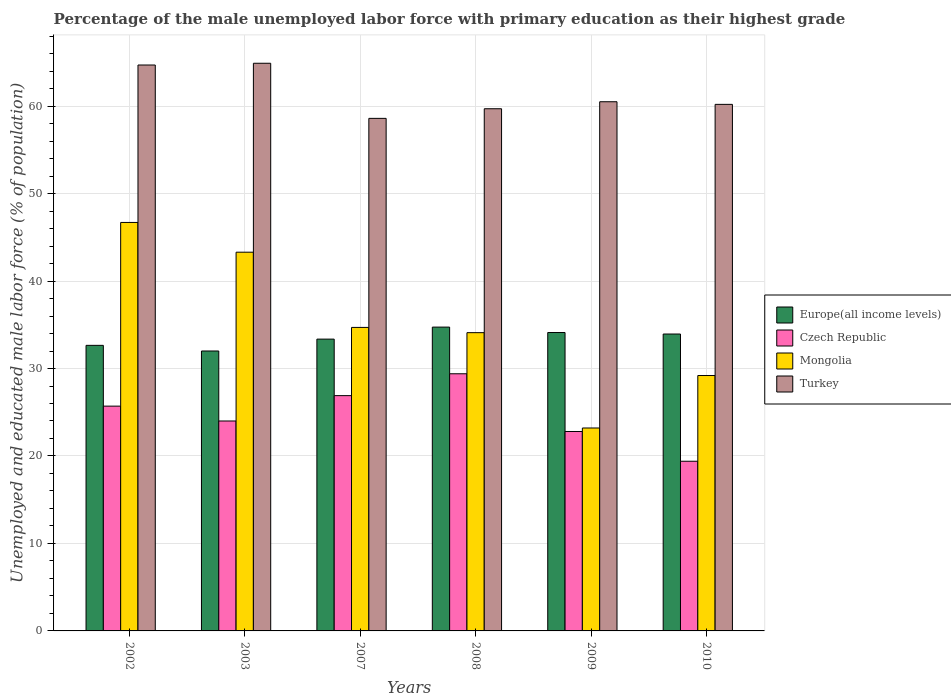How many bars are there on the 3rd tick from the right?
Your answer should be very brief. 4. What is the label of the 5th group of bars from the left?
Your answer should be compact. 2009. What is the percentage of the unemployed male labor force with primary education in Czech Republic in 2002?
Ensure brevity in your answer.  25.7. Across all years, what is the maximum percentage of the unemployed male labor force with primary education in Turkey?
Give a very brief answer. 64.9. Across all years, what is the minimum percentage of the unemployed male labor force with primary education in Mongolia?
Your answer should be compact. 23.2. What is the total percentage of the unemployed male labor force with primary education in Europe(all income levels) in the graph?
Provide a short and direct response. 200.81. What is the difference between the percentage of the unemployed male labor force with primary education in Turkey in 2002 and that in 2009?
Your answer should be compact. 4.2. What is the difference between the percentage of the unemployed male labor force with primary education in Czech Republic in 2007 and the percentage of the unemployed male labor force with primary education in Turkey in 2009?
Your response must be concise. -33.6. What is the average percentage of the unemployed male labor force with primary education in Turkey per year?
Your answer should be compact. 61.43. In the year 2003, what is the difference between the percentage of the unemployed male labor force with primary education in Europe(all income levels) and percentage of the unemployed male labor force with primary education in Mongolia?
Make the answer very short. -11.3. What is the ratio of the percentage of the unemployed male labor force with primary education in Czech Republic in 2003 to that in 2008?
Your response must be concise. 0.82. Is the percentage of the unemployed male labor force with primary education in Europe(all income levels) in 2007 less than that in 2009?
Offer a very short reply. Yes. What is the difference between the highest and the second highest percentage of the unemployed male labor force with primary education in Turkey?
Make the answer very short. 0.2. What is the difference between the highest and the lowest percentage of the unemployed male labor force with primary education in Europe(all income levels)?
Keep it short and to the point. 2.73. Is the sum of the percentage of the unemployed male labor force with primary education in Czech Republic in 2003 and 2007 greater than the maximum percentage of the unemployed male labor force with primary education in Mongolia across all years?
Provide a succinct answer. Yes. Is it the case that in every year, the sum of the percentage of the unemployed male labor force with primary education in Czech Republic and percentage of the unemployed male labor force with primary education in Mongolia is greater than the sum of percentage of the unemployed male labor force with primary education in Turkey and percentage of the unemployed male labor force with primary education in Europe(all income levels)?
Keep it short and to the point. No. What does the 1st bar from the left in 2009 represents?
Your answer should be very brief. Europe(all income levels). What does the 4th bar from the right in 2002 represents?
Provide a succinct answer. Europe(all income levels). Is it the case that in every year, the sum of the percentage of the unemployed male labor force with primary education in Czech Republic and percentage of the unemployed male labor force with primary education in Europe(all income levels) is greater than the percentage of the unemployed male labor force with primary education in Turkey?
Offer a terse response. No. Are all the bars in the graph horizontal?
Offer a very short reply. No. What is the difference between two consecutive major ticks on the Y-axis?
Ensure brevity in your answer.  10. Are the values on the major ticks of Y-axis written in scientific E-notation?
Offer a terse response. No. Where does the legend appear in the graph?
Provide a succinct answer. Center right. How are the legend labels stacked?
Your answer should be very brief. Vertical. What is the title of the graph?
Give a very brief answer. Percentage of the male unemployed labor force with primary education as their highest grade. Does "Libya" appear as one of the legend labels in the graph?
Make the answer very short. No. What is the label or title of the Y-axis?
Your answer should be very brief. Unemployed and educated male labor force (% of population). What is the Unemployed and educated male labor force (% of population) in Europe(all income levels) in 2002?
Ensure brevity in your answer.  32.65. What is the Unemployed and educated male labor force (% of population) of Czech Republic in 2002?
Provide a succinct answer. 25.7. What is the Unemployed and educated male labor force (% of population) in Mongolia in 2002?
Your answer should be very brief. 46.7. What is the Unemployed and educated male labor force (% of population) in Turkey in 2002?
Provide a succinct answer. 64.7. What is the Unemployed and educated male labor force (% of population) of Europe(all income levels) in 2003?
Provide a succinct answer. 32. What is the Unemployed and educated male labor force (% of population) of Czech Republic in 2003?
Give a very brief answer. 24. What is the Unemployed and educated male labor force (% of population) of Mongolia in 2003?
Your response must be concise. 43.3. What is the Unemployed and educated male labor force (% of population) in Turkey in 2003?
Your response must be concise. 64.9. What is the Unemployed and educated male labor force (% of population) in Europe(all income levels) in 2007?
Offer a very short reply. 33.36. What is the Unemployed and educated male labor force (% of population) of Czech Republic in 2007?
Keep it short and to the point. 26.9. What is the Unemployed and educated male labor force (% of population) of Mongolia in 2007?
Ensure brevity in your answer.  34.7. What is the Unemployed and educated male labor force (% of population) of Turkey in 2007?
Your response must be concise. 58.6. What is the Unemployed and educated male labor force (% of population) of Europe(all income levels) in 2008?
Keep it short and to the point. 34.74. What is the Unemployed and educated male labor force (% of population) in Czech Republic in 2008?
Your answer should be compact. 29.4. What is the Unemployed and educated male labor force (% of population) of Mongolia in 2008?
Your response must be concise. 34.1. What is the Unemployed and educated male labor force (% of population) in Turkey in 2008?
Offer a very short reply. 59.7. What is the Unemployed and educated male labor force (% of population) in Europe(all income levels) in 2009?
Make the answer very short. 34.12. What is the Unemployed and educated male labor force (% of population) in Czech Republic in 2009?
Provide a short and direct response. 22.8. What is the Unemployed and educated male labor force (% of population) of Mongolia in 2009?
Your answer should be compact. 23.2. What is the Unemployed and educated male labor force (% of population) in Turkey in 2009?
Your answer should be very brief. 60.5. What is the Unemployed and educated male labor force (% of population) of Europe(all income levels) in 2010?
Provide a succinct answer. 33.94. What is the Unemployed and educated male labor force (% of population) of Czech Republic in 2010?
Provide a succinct answer. 19.4. What is the Unemployed and educated male labor force (% of population) in Mongolia in 2010?
Offer a terse response. 29.2. What is the Unemployed and educated male labor force (% of population) in Turkey in 2010?
Provide a short and direct response. 60.2. Across all years, what is the maximum Unemployed and educated male labor force (% of population) of Europe(all income levels)?
Ensure brevity in your answer.  34.74. Across all years, what is the maximum Unemployed and educated male labor force (% of population) in Czech Republic?
Offer a very short reply. 29.4. Across all years, what is the maximum Unemployed and educated male labor force (% of population) of Mongolia?
Your response must be concise. 46.7. Across all years, what is the maximum Unemployed and educated male labor force (% of population) in Turkey?
Your answer should be compact. 64.9. Across all years, what is the minimum Unemployed and educated male labor force (% of population) of Europe(all income levels)?
Ensure brevity in your answer.  32. Across all years, what is the minimum Unemployed and educated male labor force (% of population) in Czech Republic?
Provide a short and direct response. 19.4. Across all years, what is the minimum Unemployed and educated male labor force (% of population) of Mongolia?
Give a very brief answer. 23.2. Across all years, what is the minimum Unemployed and educated male labor force (% of population) in Turkey?
Offer a very short reply. 58.6. What is the total Unemployed and educated male labor force (% of population) in Europe(all income levels) in the graph?
Provide a succinct answer. 200.81. What is the total Unemployed and educated male labor force (% of population) in Czech Republic in the graph?
Your answer should be very brief. 148.2. What is the total Unemployed and educated male labor force (% of population) in Mongolia in the graph?
Your answer should be compact. 211.2. What is the total Unemployed and educated male labor force (% of population) in Turkey in the graph?
Your answer should be very brief. 368.6. What is the difference between the Unemployed and educated male labor force (% of population) in Europe(all income levels) in 2002 and that in 2003?
Ensure brevity in your answer.  0.65. What is the difference between the Unemployed and educated male labor force (% of population) of Europe(all income levels) in 2002 and that in 2007?
Your answer should be compact. -0.71. What is the difference between the Unemployed and educated male labor force (% of population) of Czech Republic in 2002 and that in 2007?
Ensure brevity in your answer.  -1.2. What is the difference between the Unemployed and educated male labor force (% of population) in Turkey in 2002 and that in 2007?
Your answer should be very brief. 6.1. What is the difference between the Unemployed and educated male labor force (% of population) in Europe(all income levels) in 2002 and that in 2008?
Provide a short and direct response. -2.09. What is the difference between the Unemployed and educated male labor force (% of population) of Czech Republic in 2002 and that in 2008?
Provide a short and direct response. -3.7. What is the difference between the Unemployed and educated male labor force (% of population) of Turkey in 2002 and that in 2008?
Ensure brevity in your answer.  5. What is the difference between the Unemployed and educated male labor force (% of population) in Europe(all income levels) in 2002 and that in 2009?
Give a very brief answer. -1.47. What is the difference between the Unemployed and educated male labor force (% of population) in Mongolia in 2002 and that in 2009?
Offer a very short reply. 23.5. What is the difference between the Unemployed and educated male labor force (% of population) of Europe(all income levels) in 2002 and that in 2010?
Keep it short and to the point. -1.3. What is the difference between the Unemployed and educated male labor force (% of population) of Europe(all income levels) in 2003 and that in 2007?
Provide a succinct answer. -1.36. What is the difference between the Unemployed and educated male labor force (% of population) in Czech Republic in 2003 and that in 2007?
Make the answer very short. -2.9. What is the difference between the Unemployed and educated male labor force (% of population) of Mongolia in 2003 and that in 2007?
Offer a terse response. 8.6. What is the difference between the Unemployed and educated male labor force (% of population) in Turkey in 2003 and that in 2007?
Keep it short and to the point. 6.3. What is the difference between the Unemployed and educated male labor force (% of population) in Europe(all income levels) in 2003 and that in 2008?
Give a very brief answer. -2.73. What is the difference between the Unemployed and educated male labor force (% of population) in Czech Republic in 2003 and that in 2008?
Your answer should be compact. -5.4. What is the difference between the Unemployed and educated male labor force (% of population) in Mongolia in 2003 and that in 2008?
Your response must be concise. 9.2. What is the difference between the Unemployed and educated male labor force (% of population) of Europe(all income levels) in 2003 and that in 2009?
Provide a short and direct response. -2.11. What is the difference between the Unemployed and educated male labor force (% of population) of Czech Republic in 2003 and that in 2009?
Give a very brief answer. 1.2. What is the difference between the Unemployed and educated male labor force (% of population) of Mongolia in 2003 and that in 2009?
Your response must be concise. 20.1. What is the difference between the Unemployed and educated male labor force (% of population) of Turkey in 2003 and that in 2009?
Provide a short and direct response. 4.4. What is the difference between the Unemployed and educated male labor force (% of population) in Europe(all income levels) in 2003 and that in 2010?
Keep it short and to the point. -1.94. What is the difference between the Unemployed and educated male labor force (% of population) of Mongolia in 2003 and that in 2010?
Ensure brevity in your answer.  14.1. What is the difference between the Unemployed and educated male labor force (% of population) of Europe(all income levels) in 2007 and that in 2008?
Keep it short and to the point. -1.37. What is the difference between the Unemployed and educated male labor force (% of population) in Czech Republic in 2007 and that in 2008?
Keep it short and to the point. -2.5. What is the difference between the Unemployed and educated male labor force (% of population) in Mongolia in 2007 and that in 2008?
Offer a very short reply. 0.6. What is the difference between the Unemployed and educated male labor force (% of population) in Europe(all income levels) in 2007 and that in 2009?
Make the answer very short. -0.75. What is the difference between the Unemployed and educated male labor force (% of population) in Czech Republic in 2007 and that in 2009?
Your answer should be very brief. 4.1. What is the difference between the Unemployed and educated male labor force (% of population) of Turkey in 2007 and that in 2009?
Offer a very short reply. -1.9. What is the difference between the Unemployed and educated male labor force (% of population) of Europe(all income levels) in 2007 and that in 2010?
Your answer should be very brief. -0.58. What is the difference between the Unemployed and educated male labor force (% of population) in Mongolia in 2007 and that in 2010?
Your answer should be compact. 5.5. What is the difference between the Unemployed and educated male labor force (% of population) of Europe(all income levels) in 2008 and that in 2009?
Offer a terse response. 0.62. What is the difference between the Unemployed and educated male labor force (% of population) of Czech Republic in 2008 and that in 2009?
Make the answer very short. 6.6. What is the difference between the Unemployed and educated male labor force (% of population) in Mongolia in 2008 and that in 2009?
Provide a succinct answer. 10.9. What is the difference between the Unemployed and educated male labor force (% of population) of Europe(all income levels) in 2008 and that in 2010?
Keep it short and to the point. 0.79. What is the difference between the Unemployed and educated male labor force (% of population) of Turkey in 2008 and that in 2010?
Ensure brevity in your answer.  -0.5. What is the difference between the Unemployed and educated male labor force (% of population) of Europe(all income levels) in 2009 and that in 2010?
Your response must be concise. 0.17. What is the difference between the Unemployed and educated male labor force (% of population) of Czech Republic in 2009 and that in 2010?
Give a very brief answer. 3.4. What is the difference between the Unemployed and educated male labor force (% of population) in Europe(all income levels) in 2002 and the Unemployed and educated male labor force (% of population) in Czech Republic in 2003?
Offer a terse response. 8.65. What is the difference between the Unemployed and educated male labor force (% of population) in Europe(all income levels) in 2002 and the Unemployed and educated male labor force (% of population) in Mongolia in 2003?
Ensure brevity in your answer.  -10.65. What is the difference between the Unemployed and educated male labor force (% of population) of Europe(all income levels) in 2002 and the Unemployed and educated male labor force (% of population) of Turkey in 2003?
Ensure brevity in your answer.  -32.25. What is the difference between the Unemployed and educated male labor force (% of population) in Czech Republic in 2002 and the Unemployed and educated male labor force (% of population) in Mongolia in 2003?
Make the answer very short. -17.6. What is the difference between the Unemployed and educated male labor force (% of population) of Czech Republic in 2002 and the Unemployed and educated male labor force (% of population) of Turkey in 2003?
Make the answer very short. -39.2. What is the difference between the Unemployed and educated male labor force (% of population) in Mongolia in 2002 and the Unemployed and educated male labor force (% of population) in Turkey in 2003?
Your answer should be very brief. -18.2. What is the difference between the Unemployed and educated male labor force (% of population) in Europe(all income levels) in 2002 and the Unemployed and educated male labor force (% of population) in Czech Republic in 2007?
Offer a very short reply. 5.75. What is the difference between the Unemployed and educated male labor force (% of population) in Europe(all income levels) in 2002 and the Unemployed and educated male labor force (% of population) in Mongolia in 2007?
Your answer should be very brief. -2.05. What is the difference between the Unemployed and educated male labor force (% of population) of Europe(all income levels) in 2002 and the Unemployed and educated male labor force (% of population) of Turkey in 2007?
Ensure brevity in your answer.  -25.95. What is the difference between the Unemployed and educated male labor force (% of population) in Czech Republic in 2002 and the Unemployed and educated male labor force (% of population) in Mongolia in 2007?
Your answer should be very brief. -9. What is the difference between the Unemployed and educated male labor force (% of population) of Czech Republic in 2002 and the Unemployed and educated male labor force (% of population) of Turkey in 2007?
Make the answer very short. -32.9. What is the difference between the Unemployed and educated male labor force (% of population) in Europe(all income levels) in 2002 and the Unemployed and educated male labor force (% of population) in Czech Republic in 2008?
Provide a succinct answer. 3.25. What is the difference between the Unemployed and educated male labor force (% of population) in Europe(all income levels) in 2002 and the Unemployed and educated male labor force (% of population) in Mongolia in 2008?
Offer a terse response. -1.45. What is the difference between the Unemployed and educated male labor force (% of population) in Europe(all income levels) in 2002 and the Unemployed and educated male labor force (% of population) in Turkey in 2008?
Your answer should be compact. -27.05. What is the difference between the Unemployed and educated male labor force (% of population) in Czech Republic in 2002 and the Unemployed and educated male labor force (% of population) in Turkey in 2008?
Provide a short and direct response. -34. What is the difference between the Unemployed and educated male labor force (% of population) of Mongolia in 2002 and the Unemployed and educated male labor force (% of population) of Turkey in 2008?
Give a very brief answer. -13. What is the difference between the Unemployed and educated male labor force (% of population) in Europe(all income levels) in 2002 and the Unemployed and educated male labor force (% of population) in Czech Republic in 2009?
Provide a short and direct response. 9.85. What is the difference between the Unemployed and educated male labor force (% of population) of Europe(all income levels) in 2002 and the Unemployed and educated male labor force (% of population) of Mongolia in 2009?
Your response must be concise. 9.45. What is the difference between the Unemployed and educated male labor force (% of population) of Europe(all income levels) in 2002 and the Unemployed and educated male labor force (% of population) of Turkey in 2009?
Make the answer very short. -27.85. What is the difference between the Unemployed and educated male labor force (% of population) in Czech Republic in 2002 and the Unemployed and educated male labor force (% of population) in Mongolia in 2009?
Keep it short and to the point. 2.5. What is the difference between the Unemployed and educated male labor force (% of population) of Czech Republic in 2002 and the Unemployed and educated male labor force (% of population) of Turkey in 2009?
Provide a short and direct response. -34.8. What is the difference between the Unemployed and educated male labor force (% of population) of Europe(all income levels) in 2002 and the Unemployed and educated male labor force (% of population) of Czech Republic in 2010?
Your response must be concise. 13.25. What is the difference between the Unemployed and educated male labor force (% of population) in Europe(all income levels) in 2002 and the Unemployed and educated male labor force (% of population) in Mongolia in 2010?
Provide a succinct answer. 3.45. What is the difference between the Unemployed and educated male labor force (% of population) of Europe(all income levels) in 2002 and the Unemployed and educated male labor force (% of population) of Turkey in 2010?
Give a very brief answer. -27.55. What is the difference between the Unemployed and educated male labor force (% of population) of Czech Republic in 2002 and the Unemployed and educated male labor force (% of population) of Turkey in 2010?
Provide a succinct answer. -34.5. What is the difference between the Unemployed and educated male labor force (% of population) in Europe(all income levels) in 2003 and the Unemployed and educated male labor force (% of population) in Czech Republic in 2007?
Provide a succinct answer. 5.1. What is the difference between the Unemployed and educated male labor force (% of population) of Europe(all income levels) in 2003 and the Unemployed and educated male labor force (% of population) of Mongolia in 2007?
Keep it short and to the point. -2.7. What is the difference between the Unemployed and educated male labor force (% of population) in Europe(all income levels) in 2003 and the Unemployed and educated male labor force (% of population) in Turkey in 2007?
Make the answer very short. -26.6. What is the difference between the Unemployed and educated male labor force (% of population) in Czech Republic in 2003 and the Unemployed and educated male labor force (% of population) in Mongolia in 2007?
Provide a succinct answer. -10.7. What is the difference between the Unemployed and educated male labor force (% of population) in Czech Republic in 2003 and the Unemployed and educated male labor force (% of population) in Turkey in 2007?
Offer a terse response. -34.6. What is the difference between the Unemployed and educated male labor force (% of population) of Mongolia in 2003 and the Unemployed and educated male labor force (% of population) of Turkey in 2007?
Keep it short and to the point. -15.3. What is the difference between the Unemployed and educated male labor force (% of population) of Europe(all income levels) in 2003 and the Unemployed and educated male labor force (% of population) of Czech Republic in 2008?
Provide a succinct answer. 2.6. What is the difference between the Unemployed and educated male labor force (% of population) of Europe(all income levels) in 2003 and the Unemployed and educated male labor force (% of population) of Mongolia in 2008?
Provide a short and direct response. -2.1. What is the difference between the Unemployed and educated male labor force (% of population) in Europe(all income levels) in 2003 and the Unemployed and educated male labor force (% of population) in Turkey in 2008?
Offer a very short reply. -27.7. What is the difference between the Unemployed and educated male labor force (% of population) of Czech Republic in 2003 and the Unemployed and educated male labor force (% of population) of Turkey in 2008?
Your answer should be very brief. -35.7. What is the difference between the Unemployed and educated male labor force (% of population) in Mongolia in 2003 and the Unemployed and educated male labor force (% of population) in Turkey in 2008?
Provide a succinct answer. -16.4. What is the difference between the Unemployed and educated male labor force (% of population) in Europe(all income levels) in 2003 and the Unemployed and educated male labor force (% of population) in Czech Republic in 2009?
Your answer should be compact. 9.2. What is the difference between the Unemployed and educated male labor force (% of population) of Europe(all income levels) in 2003 and the Unemployed and educated male labor force (% of population) of Mongolia in 2009?
Give a very brief answer. 8.8. What is the difference between the Unemployed and educated male labor force (% of population) in Europe(all income levels) in 2003 and the Unemployed and educated male labor force (% of population) in Turkey in 2009?
Provide a short and direct response. -28.5. What is the difference between the Unemployed and educated male labor force (% of population) of Czech Republic in 2003 and the Unemployed and educated male labor force (% of population) of Mongolia in 2009?
Offer a terse response. 0.8. What is the difference between the Unemployed and educated male labor force (% of population) of Czech Republic in 2003 and the Unemployed and educated male labor force (% of population) of Turkey in 2009?
Make the answer very short. -36.5. What is the difference between the Unemployed and educated male labor force (% of population) in Mongolia in 2003 and the Unemployed and educated male labor force (% of population) in Turkey in 2009?
Provide a succinct answer. -17.2. What is the difference between the Unemployed and educated male labor force (% of population) in Europe(all income levels) in 2003 and the Unemployed and educated male labor force (% of population) in Czech Republic in 2010?
Your answer should be very brief. 12.6. What is the difference between the Unemployed and educated male labor force (% of population) of Europe(all income levels) in 2003 and the Unemployed and educated male labor force (% of population) of Mongolia in 2010?
Keep it short and to the point. 2.8. What is the difference between the Unemployed and educated male labor force (% of population) in Europe(all income levels) in 2003 and the Unemployed and educated male labor force (% of population) in Turkey in 2010?
Give a very brief answer. -28.2. What is the difference between the Unemployed and educated male labor force (% of population) in Czech Republic in 2003 and the Unemployed and educated male labor force (% of population) in Turkey in 2010?
Your answer should be very brief. -36.2. What is the difference between the Unemployed and educated male labor force (% of population) in Mongolia in 2003 and the Unemployed and educated male labor force (% of population) in Turkey in 2010?
Your answer should be very brief. -16.9. What is the difference between the Unemployed and educated male labor force (% of population) of Europe(all income levels) in 2007 and the Unemployed and educated male labor force (% of population) of Czech Republic in 2008?
Your answer should be compact. 3.96. What is the difference between the Unemployed and educated male labor force (% of population) of Europe(all income levels) in 2007 and the Unemployed and educated male labor force (% of population) of Mongolia in 2008?
Offer a very short reply. -0.74. What is the difference between the Unemployed and educated male labor force (% of population) of Europe(all income levels) in 2007 and the Unemployed and educated male labor force (% of population) of Turkey in 2008?
Make the answer very short. -26.34. What is the difference between the Unemployed and educated male labor force (% of population) in Czech Republic in 2007 and the Unemployed and educated male labor force (% of population) in Mongolia in 2008?
Your response must be concise. -7.2. What is the difference between the Unemployed and educated male labor force (% of population) in Czech Republic in 2007 and the Unemployed and educated male labor force (% of population) in Turkey in 2008?
Provide a short and direct response. -32.8. What is the difference between the Unemployed and educated male labor force (% of population) of Mongolia in 2007 and the Unemployed and educated male labor force (% of population) of Turkey in 2008?
Provide a short and direct response. -25. What is the difference between the Unemployed and educated male labor force (% of population) in Europe(all income levels) in 2007 and the Unemployed and educated male labor force (% of population) in Czech Republic in 2009?
Offer a very short reply. 10.56. What is the difference between the Unemployed and educated male labor force (% of population) in Europe(all income levels) in 2007 and the Unemployed and educated male labor force (% of population) in Mongolia in 2009?
Provide a succinct answer. 10.16. What is the difference between the Unemployed and educated male labor force (% of population) of Europe(all income levels) in 2007 and the Unemployed and educated male labor force (% of population) of Turkey in 2009?
Your answer should be compact. -27.14. What is the difference between the Unemployed and educated male labor force (% of population) of Czech Republic in 2007 and the Unemployed and educated male labor force (% of population) of Turkey in 2009?
Give a very brief answer. -33.6. What is the difference between the Unemployed and educated male labor force (% of population) in Mongolia in 2007 and the Unemployed and educated male labor force (% of population) in Turkey in 2009?
Provide a short and direct response. -25.8. What is the difference between the Unemployed and educated male labor force (% of population) in Europe(all income levels) in 2007 and the Unemployed and educated male labor force (% of population) in Czech Republic in 2010?
Offer a terse response. 13.96. What is the difference between the Unemployed and educated male labor force (% of population) in Europe(all income levels) in 2007 and the Unemployed and educated male labor force (% of population) in Mongolia in 2010?
Make the answer very short. 4.16. What is the difference between the Unemployed and educated male labor force (% of population) of Europe(all income levels) in 2007 and the Unemployed and educated male labor force (% of population) of Turkey in 2010?
Provide a succinct answer. -26.84. What is the difference between the Unemployed and educated male labor force (% of population) in Czech Republic in 2007 and the Unemployed and educated male labor force (% of population) in Turkey in 2010?
Offer a very short reply. -33.3. What is the difference between the Unemployed and educated male labor force (% of population) of Mongolia in 2007 and the Unemployed and educated male labor force (% of population) of Turkey in 2010?
Your response must be concise. -25.5. What is the difference between the Unemployed and educated male labor force (% of population) in Europe(all income levels) in 2008 and the Unemployed and educated male labor force (% of population) in Czech Republic in 2009?
Your answer should be very brief. 11.94. What is the difference between the Unemployed and educated male labor force (% of population) in Europe(all income levels) in 2008 and the Unemployed and educated male labor force (% of population) in Mongolia in 2009?
Provide a succinct answer. 11.54. What is the difference between the Unemployed and educated male labor force (% of population) in Europe(all income levels) in 2008 and the Unemployed and educated male labor force (% of population) in Turkey in 2009?
Provide a succinct answer. -25.76. What is the difference between the Unemployed and educated male labor force (% of population) of Czech Republic in 2008 and the Unemployed and educated male labor force (% of population) of Turkey in 2009?
Give a very brief answer. -31.1. What is the difference between the Unemployed and educated male labor force (% of population) of Mongolia in 2008 and the Unemployed and educated male labor force (% of population) of Turkey in 2009?
Offer a very short reply. -26.4. What is the difference between the Unemployed and educated male labor force (% of population) of Europe(all income levels) in 2008 and the Unemployed and educated male labor force (% of population) of Czech Republic in 2010?
Make the answer very short. 15.34. What is the difference between the Unemployed and educated male labor force (% of population) of Europe(all income levels) in 2008 and the Unemployed and educated male labor force (% of population) of Mongolia in 2010?
Your answer should be very brief. 5.54. What is the difference between the Unemployed and educated male labor force (% of population) of Europe(all income levels) in 2008 and the Unemployed and educated male labor force (% of population) of Turkey in 2010?
Make the answer very short. -25.46. What is the difference between the Unemployed and educated male labor force (% of population) of Czech Republic in 2008 and the Unemployed and educated male labor force (% of population) of Mongolia in 2010?
Your response must be concise. 0.2. What is the difference between the Unemployed and educated male labor force (% of population) of Czech Republic in 2008 and the Unemployed and educated male labor force (% of population) of Turkey in 2010?
Offer a very short reply. -30.8. What is the difference between the Unemployed and educated male labor force (% of population) in Mongolia in 2008 and the Unemployed and educated male labor force (% of population) in Turkey in 2010?
Your answer should be compact. -26.1. What is the difference between the Unemployed and educated male labor force (% of population) in Europe(all income levels) in 2009 and the Unemployed and educated male labor force (% of population) in Czech Republic in 2010?
Your answer should be very brief. 14.72. What is the difference between the Unemployed and educated male labor force (% of population) of Europe(all income levels) in 2009 and the Unemployed and educated male labor force (% of population) of Mongolia in 2010?
Give a very brief answer. 4.92. What is the difference between the Unemployed and educated male labor force (% of population) of Europe(all income levels) in 2009 and the Unemployed and educated male labor force (% of population) of Turkey in 2010?
Provide a succinct answer. -26.08. What is the difference between the Unemployed and educated male labor force (% of population) in Czech Republic in 2009 and the Unemployed and educated male labor force (% of population) in Mongolia in 2010?
Your answer should be very brief. -6.4. What is the difference between the Unemployed and educated male labor force (% of population) of Czech Republic in 2009 and the Unemployed and educated male labor force (% of population) of Turkey in 2010?
Your answer should be compact. -37.4. What is the difference between the Unemployed and educated male labor force (% of population) in Mongolia in 2009 and the Unemployed and educated male labor force (% of population) in Turkey in 2010?
Your response must be concise. -37. What is the average Unemployed and educated male labor force (% of population) in Europe(all income levels) per year?
Provide a short and direct response. 33.47. What is the average Unemployed and educated male labor force (% of population) in Czech Republic per year?
Offer a terse response. 24.7. What is the average Unemployed and educated male labor force (% of population) in Mongolia per year?
Your answer should be very brief. 35.2. What is the average Unemployed and educated male labor force (% of population) of Turkey per year?
Ensure brevity in your answer.  61.43. In the year 2002, what is the difference between the Unemployed and educated male labor force (% of population) in Europe(all income levels) and Unemployed and educated male labor force (% of population) in Czech Republic?
Ensure brevity in your answer.  6.95. In the year 2002, what is the difference between the Unemployed and educated male labor force (% of population) in Europe(all income levels) and Unemployed and educated male labor force (% of population) in Mongolia?
Offer a terse response. -14.05. In the year 2002, what is the difference between the Unemployed and educated male labor force (% of population) of Europe(all income levels) and Unemployed and educated male labor force (% of population) of Turkey?
Keep it short and to the point. -32.05. In the year 2002, what is the difference between the Unemployed and educated male labor force (% of population) of Czech Republic and Unemployed and educated male labor force (% of population) of Turkey?
Offer a very short reply. -39. In the year 2003, what is the difference between the Unemployed and educated male labor force (% of population) of Europe(all income levels) and Unemployed and educated male labor force (% of population) of Czech Republic?
Your response must be concise. 8. In the year 2003, what is the difference between the Unemployed and educated male labor force (% of population) in Europe(all income levels) and Unemployed and educated male labor force (% of population) in Mongolia?
Your answer should be compact. -11.3. In the year 2003, what is the difference between the Unemployed and educated male labor force (% of population) in Europe(all income levels) and Unemployed and educated male labor force (% of population) in Turkey?
Ensure brevity in your answer.  -32.9. In the year 2003, what is the difference between the Unemployed and educated male labor force (% of population) of Czech Republic and Unemployed and educated male labor force (% of population) of Mongolia?
Your answer should be compact. -19.3. In the year 2003, what is the difference between the Unemployed and educated male labor force (% of population) of Czech Republic and Unemployed and educated male labor force (% of population) of Turkey?
Keep it short and to the point. -40.9. In the year 2003, what is the difference between the Unemployed and educated male labor force (% of population) in Mongolia and Unemployed and educated male labor force (% of population) in Turkey?
Provide a succinct answer. -21.6. In the year 2007, what is the difference between the Unemployed and educated male labor force (% of population) in Europe(all income levels) and Unemployed and educated male labor force (% of population) in Czech Republic?
Make the answer very short. 6.46. In the year 2007, what is the difference between the Unemployed and educated male labor force (% of population) of Europe(all income levels) and Unemployed and educated male labor force (% of population) of Mongolia?
Your response must be concise. -1.34. In the year 2007, what is the difference between the Unemployed and educated male labor force (% of population) in Europe(all income levels) and Unemployed and educated male labor force (% of population) in Turkey?
Offer a very short reply. -25.24. In the year 2007, what is the difference between the Unemployed and educated male labor force (% of population) in Czech Republic and Unemployed and educated male labor force (% of population) in Turkey?
Your answer should be very brief. -31.7. In the year 2007, what is the difference between the Unemployed and educated male labor force (% of population) in Mongolia and Unemployed and educated male labor force (% of population) in Turkey?
Provide a short and direct response. -23.9. In the year 2008, what is the difference between the Unemployed and educated male labor force (% of population) of Europe(all income levels) and Unemployed and educated male labor force (% of population) of Czech Republic?
Your response must be concise. 5.34. In the year 2008, what is the difference between the Unemployed and educated male labor force (% of population) of Europe(all income levels) and Unemployed and educated male labor force (% of population) of Mongolia?
Your response must be concise. 0.64. In the year 2008, what is the difference between the Unemployed and educated male labor force (% of population) of Europe(all income levels) and Unemployed and educated male labor force (% of population) of Turkey?
Provide a short and direct response. -24.96. In the year 2008, what is the difference between the Unemployed and educated male labor force (% of population) in Czech Republic and Unemployed and educated male labor force (% of population) in Mongolia?
Provide a short and direct response. -4.7. In the year 2008, what is the difference between the Unemployed and educated male labor force (% of population) in Czech Republic and Unemployed and educated male labor force (% of population) in Turkey?
Offer a very short reply. -30.3. In the year 2008, what is the difference between the Unemployed and educated male labor force (% of population) of Mongolia and Unemployed and educated male labor force (% of population) of Turkey?
Your answer should be compact. -25.6. In the year 2009, what is the difference between the Unemployed and educated male labor force (% of population) of Europe(all income levels) and Unemployed and educated male labor force (% of population) of Czech Republic?
Ensure brevity in your answer.  11.32. In the year 2009, what is the difference between the Unemployed and educated male labor force (% of population) of Europe(all income levels) and Unemployed and educated male labor force (% of population) of Mongolia?
Ensure brevity in your answer.  10.92. In the year 2009, what is the difference between the Unemployed and educated male labor force (% of population) in Europe(all income levels) and Unemployed and educated male labor force (% of population) in Turkey?
Your response must be concise. -26.38. In the year 2009, what is the difference between the Unemployed and educated male labor force (% of population) in Czech Republic and Unemployed and educated male labor force (% of population) in Turkey?
Your answer should be very brief. -37.7. In the year 2009, what is the difference between the Unemployed and educated male labor force (% of population) of Mongolia and Unemployed and educated male labor force (% of population) of Turkey?
Your response must be concise. -37.3. In the year 2010, what is the difference between the Unemployed and educated male labor force (% of population) in Europe(all income levels) and Unemployed and educated male labor force (% of population) in Czech Republic?
Offer a very short reply. 14.54. In the year 2010, what is the difference between the Unemployed and educated male labor force (% of population) of Europe(all income levels) and Unemployed and educated male labor force (% of population) of Mongolia?
Ensure brevity in your answer.  4.74. In the year 2010, what is the difference between the Unemployed and educated male labor force (% of population) in Europe(all income levels) and Unemployed and educated male labor force (% of population) in Turkey?
Provide a short and direct response. -26.26. In the year 2010, what is the difference between the Unemployed and educated male labor force (% of population) of Czech Republic and Unemployed and educated male labor force (% of population) of Turkey?
Ensure brevity in your answer.  -40.8. In the year 2010, what is the difference between the Unemployed and educated male labor force (% of population) in Mongolia and Unemployed and educated male labor force (% of population) in Turkey?
Keep it short and to the point. -31. What is the ratio of the Unemployed and educated male labor force (% of population) in Europe(all income levels) in 2002 to that in 2003?
Keep it short and to the point. 1.02. What is the ratio of the Unemployed and educated male labor force (% of population) of Czech Republic in 2002 to that in 2003?
Your answer should be compact. 1.07. What is the ratio of the Unemployed and educated male labor force (% of population) of Mongolia in 2002 to that in 2003?
Provide a succinct answer. 1.08. What is the ratio of the Unemployed and educated male labor force (% of population) in Turkey in 2002 to that in 2003?
Give a very brief answer. 1. What is the ratio of the Unemployed and educated male labor force (% of population) of Europe(all income levels) in 2002 to that in 2007?
Provide a short and direct response. 0.98. What is the ratio of the Unemployed and educated male labor force (% of population) of Czech Republic in 2002 to that in 2007?
Your answer should be very brief. 0.96. What is the ratio of the Unemployed and educated male labor force (% of population) of Mongolia in 2002 to that in 2007?
Provide a short and direct response. 1.35. What is the ratio of the Unemployed and educated male labor force (% of population) in Turkey in 2002 to that in 2007?
Give a very brief answer. 1.1. What is the ratio of the Unemployed and educated male labor force (% of population) in Europe(all income levels) in 2002 to that in 2008?
Ensure brevity in your answer.  0.94. What is the ratio of the Unemployed and educated male labor force (% of population) of Czech Republic in 2002 to that in 2008?
Offer a terse response. 0.87. What is the ratio of the Unemployed and educated male labor force (% of population) in Mongolia in 2002 to that in 2008?
Your answer should be compact. 1.37. What is the ratio of the Unemployed and educated male labor force (% of population) of Turkey in 2002 to that in 2008?
Your answer should be very brief. 1.08. What is the ratio of the Unemployed and educated male labor force (% of population) of Czech Republic in 2002 to that in 2009?
Offer a terse response. 1.13. What is the ratio of the Unemployed and educated male labor force (% of population) of Mongolia in 2002 to that in 2009?
Make the answer very short. 2.01. What is the ratio of the Unemployed and educated male labor force (% of population) in Turkey in 2002 to that in 2009?
Give a very brief answer. 1.07. What is the ratio of the Unemployed and educated male labor force (% of population) of Europe(all income levels) in 2002 to that in 2010?
Your response must be concise. 0.96. What is the ratio of the Unemployed and educated male labor force (% of population) in Czech Republic in 2002 to that in 2010?
Give a very brief answer. 1.32. What is the ratio of the Unemployed and educated male labor force (% of population) in Mongolia in 2002 to that in 2010?
Offer a terse response. 1.6. What is the ratio of the Unemployed and educated male labor force (% of population) in Turkey in 2002 to that in 2010?
Ensure brevity in your answer.  1.07. What is the ratio of the Unemployed and educated male labor force (% of population) in Europe(all income levels) in 2003 to that in 2007?
Offer a very short reply. 0.96. What is the ratio of the Unemployed and educated male labor force (% of population) in Czech Republic in 2003 to that in 2007?
Make the answer very short. 0.89. What is the ratio of the Unemployed and educated male labor force (% of population) of Mongolia in 2003 to that in 2007?
Keep it short and to the point. 1.25. What is the ratio of the Unemployed and educated male labor force (% of population) of Turkey in 2003 to that in 2007?
Ensure brevity in your answer.  1.11. What is the ratio of the Unemployed and educated male labor force (% of population) of Europe(all income levels) in 2003 to that in 2008?
Give a very brief answer. 0.92. What is the ratio of the Unemployed and educated male labor force (% of population) in Czech Republic in 2003 to that in 2008?
Give a very brief answer. 0.82. What is the ratio of the Unemployed and educated male labor force (% of population) of Mongolia in 2003 to that in 2008?
Ensure brevity in your answer.  1.27. What is the ratio of the Unemployed and educated male labor force (% of population) in Turkey in 2003 to that in 2008?
Provide a short and direct response. 1.09. What is the ratio of the Unemployed and educated male labor force (% of population) in Europe(all income levels) in 2003 to that in 2009?
Your answer should be very brief. 0.94. What is the ratio of the Unemployed and educated male labor force (% of population) in Czech Republic in 2003 to that in 2009?
Give a very brief answer. 1.05. What is the ratio of the Unemployed and educated male labor force (% of population) of Mongolia in 2003 to that in 2009?
Offer a very short reply. 1.87. What is the ratio of the Unemployed and educated male labor force (% of population) of Turkey in 2003 to that in 2009?
Make the answer very short. 1.07. What is the ratio of the Unemployed and educated male labor force (% of population) in Europe(all income levels) in 2003 to that in 2010?
Your answer should be very brief. 0.94. What is the ratio of the Unemployed and educated male labor force (% of population) in Czech Republic in 2003 to that in 2010?
Make the answer very short. 1.24. What is the ratio of the Unemployed and educated male labor force (% of population) of Mongolia in 2003 to that in 2010?
Provide a succinct answer. 1.48. What is the ratio of the Unemployed and educated male labor force (% of population) in Turkey in 2003 to that in 2010?
Your answer should be very brief. 1.08. What is the ratio of the Unemployed and educated male labor force (% of population) of Europe(all income levels) in 2007 to that in 2008?
Provide a short and direct response. 0.96. What is the ratio of the Unemployed and educated male labor force (% of population) of Czech Republic in 2007 to that in 2008?
Provide a succinct answer. 0.92. What is the ratio of the Unemployed and educated male labor force (% of population) in Mongolia in 2007 to that in 2008?
Make the answer very short. 1.02. What is the ratio of the Unemployed and educated male labor force (% of population) in Turkey in 2007 to that in 2008?
Ensure brevity in your answer.  0.98. What is the ratio of the Unemployed and educated male labor force (% of population) in Europe(all income levels) in 2007 to that in 2009?
Your answer should be very brief. 0.98. What is the ratio of the Unemployed and educated male labor force (% of population) in Czech Republic in 2007 to that in 2009?
Make the answer very short. 1.18. What is the ratio of the Unemployed and educated male labor force (% of population) in Mongolia in 2007 to that in 2009?
Provide a short and direct response. 1.5. What is the ratio of the Unemployed and educated male labor force (% of population) of Turkey in 2007 to that in 2009?
Keep it short and to the point. 0.97. What is the ratio of the Unemployed and educated male labor force (% of population) of Europe(all income levels) in 2007 to that in 2010?
Keep it short and to the point. 0.98. What is the ratio of the Unemployed and educated male labor force (% of population) in Czech Republic in 2007 to that in 2010?
Ensure brevity in your answer.  1.39. What is the ratio of the Unemployed and educated male labor force (% of population) in Mongolia in 2007 to that in 2010?
Provide a succinct answer. 1.19. What is the ratio of the Unemployed and educated male labor force (% of population) of Turkey in 2007 to that in 2010?
Your response must be concise. 0.97. What is the ratio of the Unemployed and educated male labor force (% of population) in Europe(all income levels) in 2008 to that in 2009?
Your answer should be compact. 1.02. What is the ratio of the Unemployed and educated male labor force (% of population) in Czech Republic in 2008 to that in 2009?
Provide a short and direct response. 1.29. What is the ratio of the Unemployed and educated male labor force (% of population) in Mongolia in 2008 to that in 2009?
Keep it short and to the point. 1.47. What is the ratio of the Unemployed and educated male labor force (% of population) of Europe(all income levels) in 2008 to that in 2010?
Provide a succinct answer. 1.02. What is the ratio of the Unemployed and educated male labor force (% of population) in Czech Republic in 2008 to that in 2010?
Provide a short and direct response. 1.52. What is the ratio of the Unemployed and educated male labor force (% of population) in Mongolia in 2008 to that in 2010?
Your answer should be very brief. 1.17. What is the ratio of the Unemployed and educated male labor force (% of population) of Turkey in 2008 to that in 2010?
Provide a short and direct response. 0.99. What is the ratio of the Unemployed and educated male labor force (% of population) of Czech Republic in 2009 to that in 2010?
Give a very brief answer. 1.18. What is the ratio of the Unemployed and educated male labor force (% of population) of Mongolia in 2009 to that in 2010?
Offer a very short reply. 0.79. What is the difference between the highest and the second highest Unemployed and educated male labor force (% of population) of Europe(all income levels)?
Offer a very short reply. 0.62. What is the difference between the highest and the second highest Unemployed and educated male labor force (% of population) in Turkey?
Your response must be concise. 0.2. What is the difference between the highest and the lowest Unemployed and educated male labor force (% of population) in Europe(all income levels)?
Your answer should be very brief. 2.73. What is the difference between the highest and the lowest Unemployed and educated male labor force (% of population) in Mongolia?
Make the answer very short. 23.5. What is the difference between the highest and the lowest Unemployed and educated male labor force (% of population) in Turkey?
Provide a succinct answer. 6.3. 